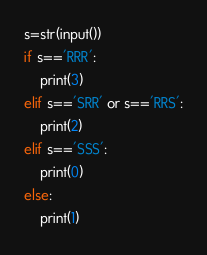<code> <loc_0><loc_0><loc_500><loc_500><_Python_>s=str(input())
if s=='RRR':
    print(3)
elif s=='SRR' or s=='RRS':
    print(2)
elif s=='SSS':
    print(0)
else:
    print(1)
</code> 